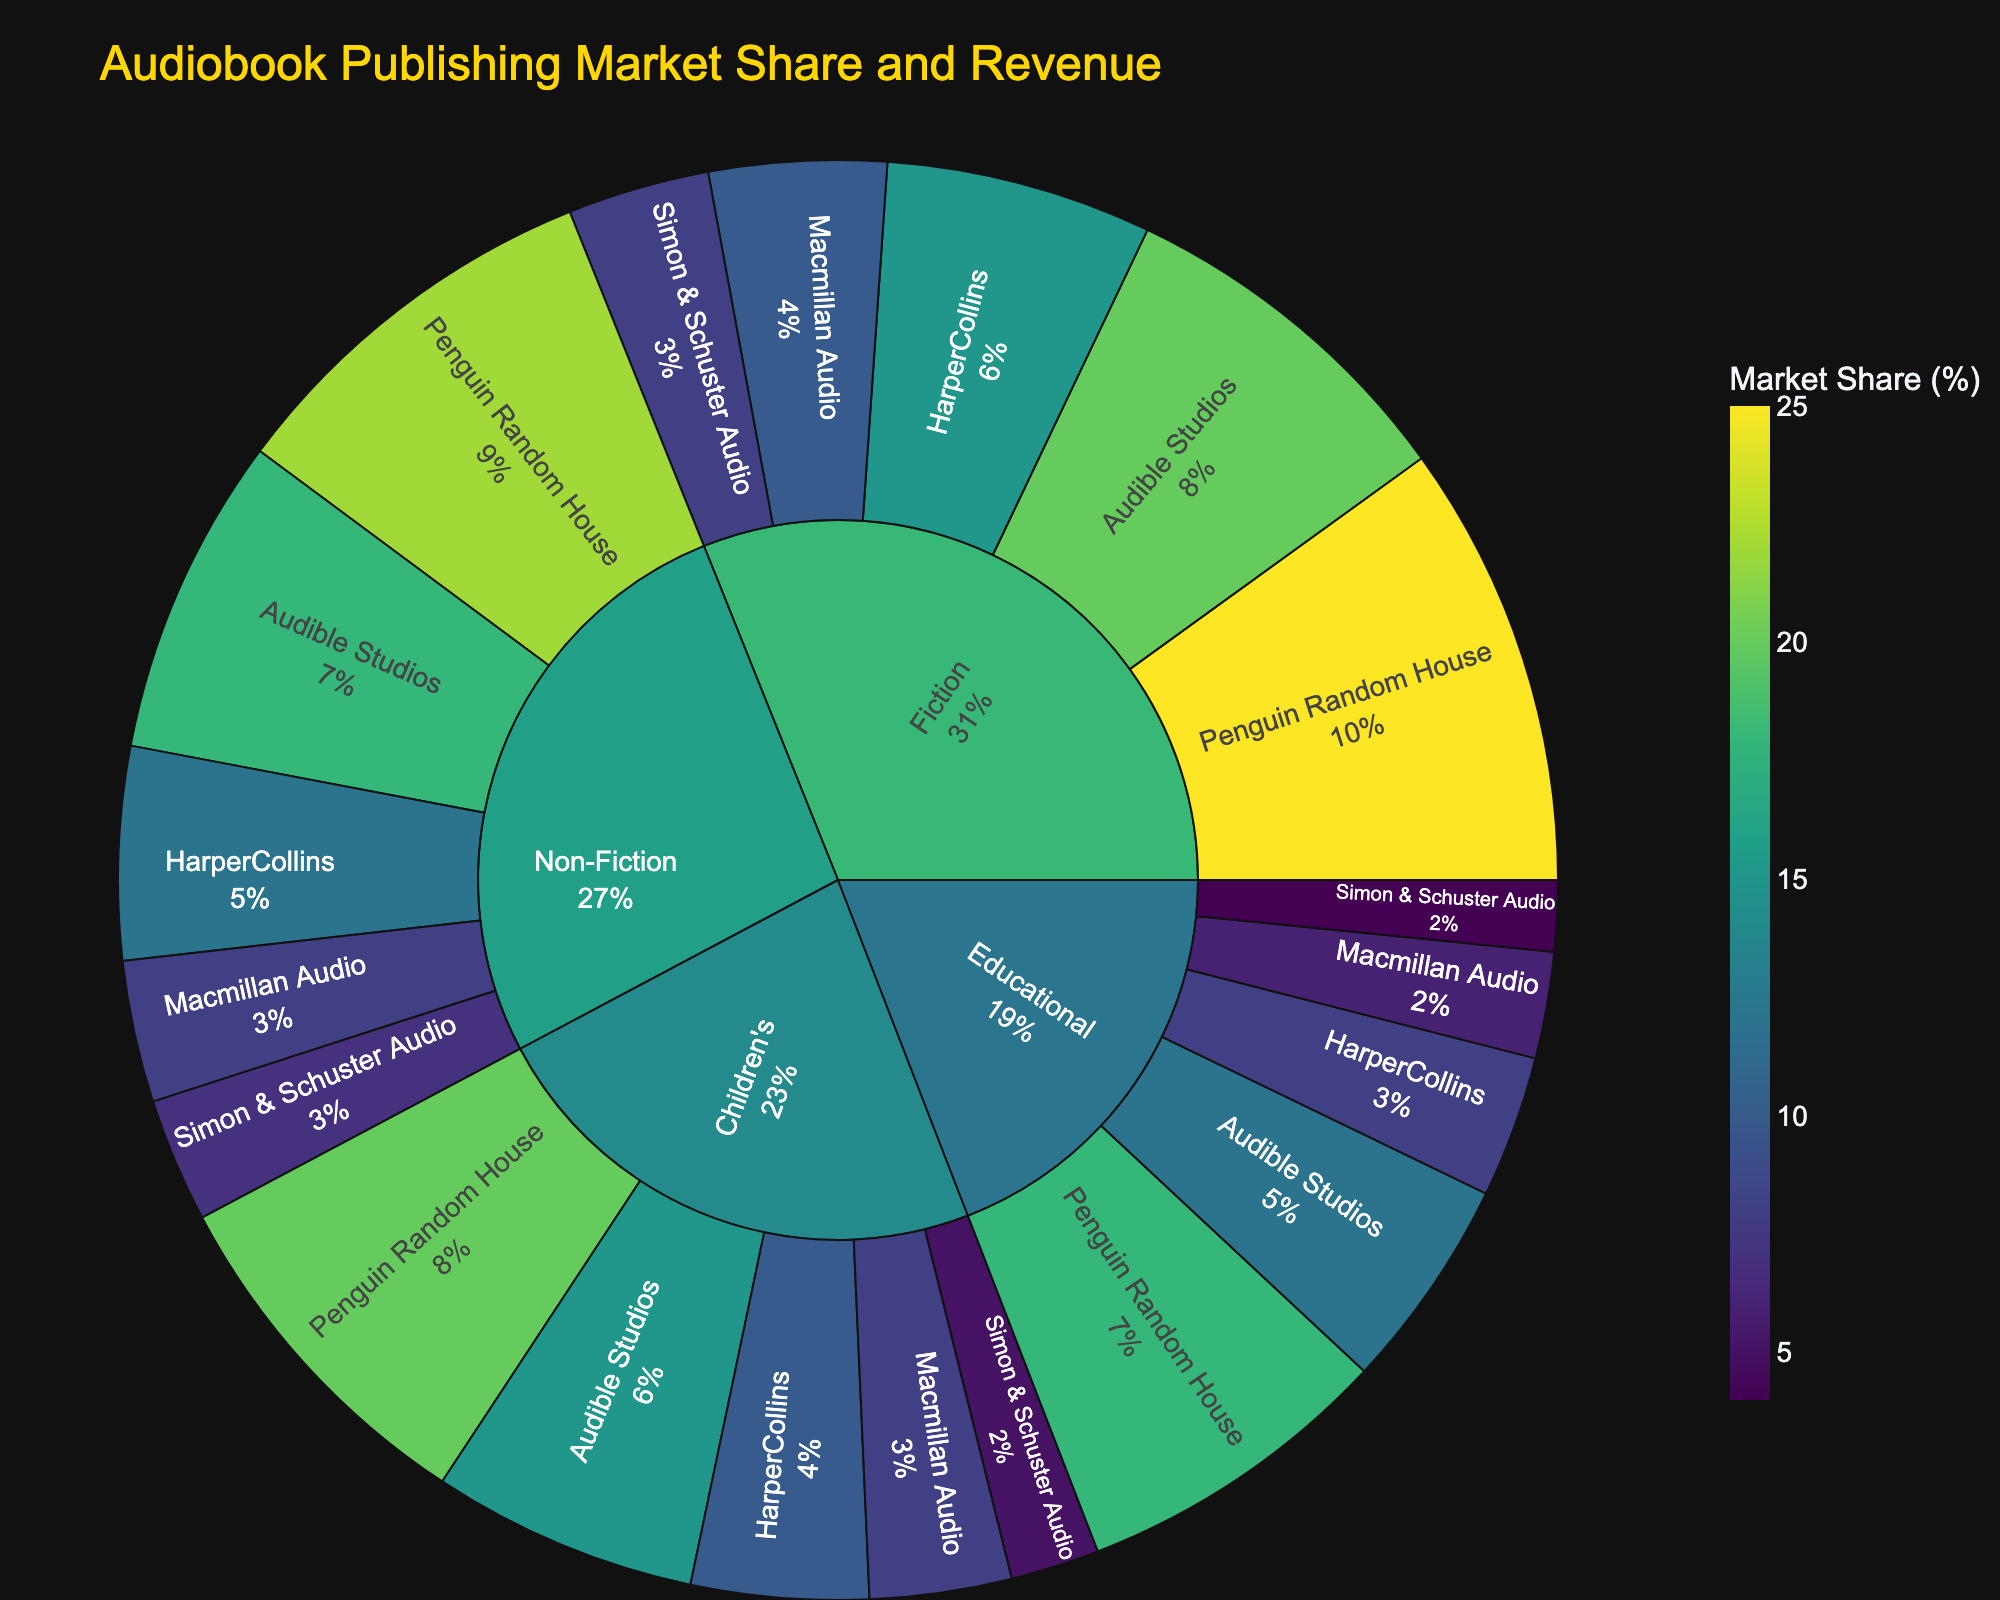What is the market share of Penguin Random House in the Fiction category? Locate the Fiction category in the Sunburst Plot. Within the Fiction segment, find Penguin Random House. The hover tooltip indicates the market share as a percentage.
Answer: 25% Which publishing company has the highest revenue in the Non-Fiction category? Identify the Non-Fiction category in the Sunburst Plot. Within Non-Fiction, compare the revenue figures for each publishing company. The publisher with the highest revenue is Penguin Random House at $440,000,000.
Answer: Penguin Random House What is the total revenue generated by Audible Studios in all categories? Locate Audible Studios in the Sunburst Plot segments for Fiction, Non-Fiction, Children's, and Educational categories. Sum the revenues: $400,000,000 (Fiction) + $360,000,000 (Non-Fiction) + $300,000,000 (Children's) + $240,000,000 (Educational) = $1,300,000,000.
Answer: $1,300,000,000 How do the revenues for HarperCollins compare between the Children's and Educational categories? Locate HarperCollins within the Children's and Educational segments. Compare their revenues: $200,000,000 (Children's) vs. $160,000,000 (Educational). HarperCollins generates more revenue in Children's by $40,000,000.
Answer: $40,000,000 more in Children's Which category has the largest overall revenue share? Examine the largest outermost segments in the Sunburst Plot. The Fiction category has the largest overall revenue based on its visual proportion.
Answer: Fiction What percentage of the total market share does Simon & Schuster Audio hold in the Educational category? Locate Simon & Schuster Audio within the Educational segment. The hover tooltip shows the market share percentage, which is 4%.
Answer: 4% How much more revenue does Penguin Random House generate in Non-Fiction compared to Macmillan Audio in the same category? Locate Penguin Random House and Macmillan Audio within Non-Fiction. Compare their revenues: $440,000,000 (Penguin Random House) - $160,000,000 (Macmillan Audio) = $280,000,000.
Answer: $280,000,000 What is the combined revenue of Macmillan Audio across all categories? Locate Macmillan Audio in each category segment: Fiction, Non-Fiction, Children's, Educational. Sum the revenues: $200,000,000 (Fiction) + $160,000,000 (Non-Fiction) + $160,000,000 (Children's) + $120,000,000 (Educational) = $640,000,000.
Answer: $640,000,000 Which category has the smallest revenue for Simon & Schuster Audio? Locate Simon & Schuster Audio in all category segments. Compare the revenue values: Fiction ($160,000,000), Non-Fiction ($140,000,000), Children's ($100,000,000), and Educational ($80,000,000). The Educational category has the smallest revenue.
Answer: Educational What is the total market share of Penguin Random House across all categories? Locate Penguin Random House in each category segment and sum their market shares: 25% (Fiction) + 22% (Non-Fiction) + 20% (Children's) + 18% (Educational) = 85%.
Answer: 85% 